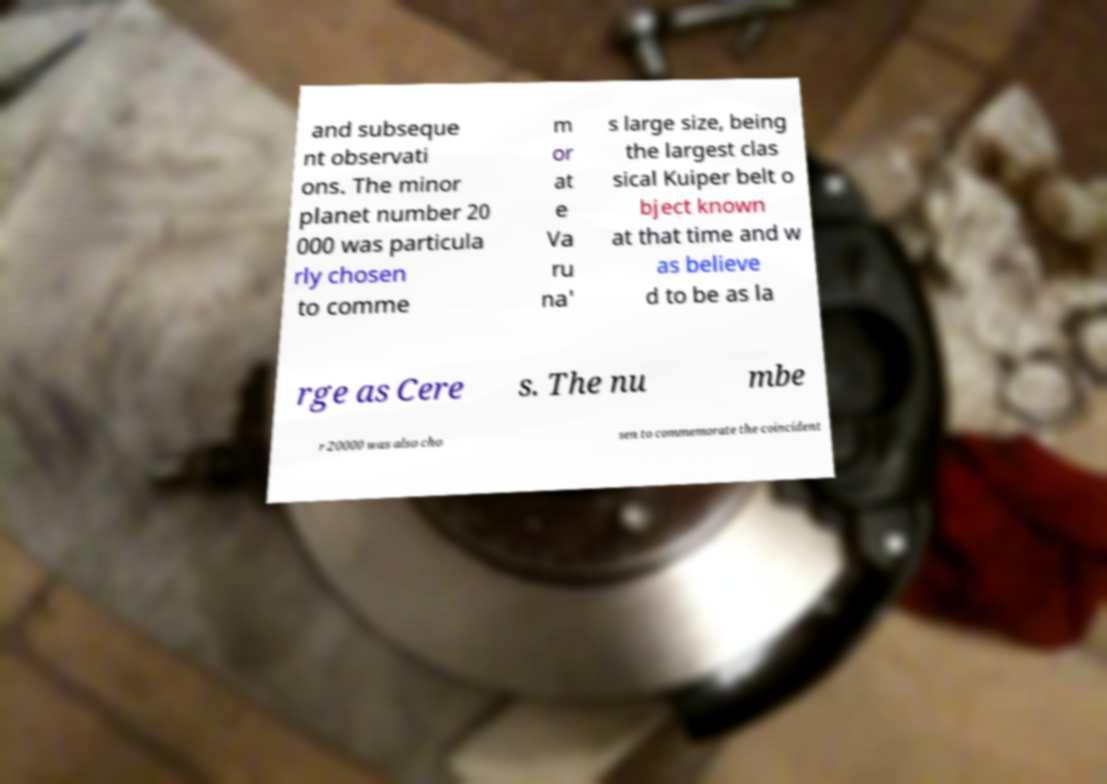Can you read and provide the text displayed in the image?This photo seems to have some interesting text. Can you extract and type it out for me? and subseque nt observati ons. The minor planet number 20 000 was particula rly chosen to comme m or at e Va ru na' s large size, being the largest clas sical Kuiper belt o bject known at that time and w as believe d to be as la rge as Cere s. The nu mbe r 20000 was also cho sen to commemorate the coincident 